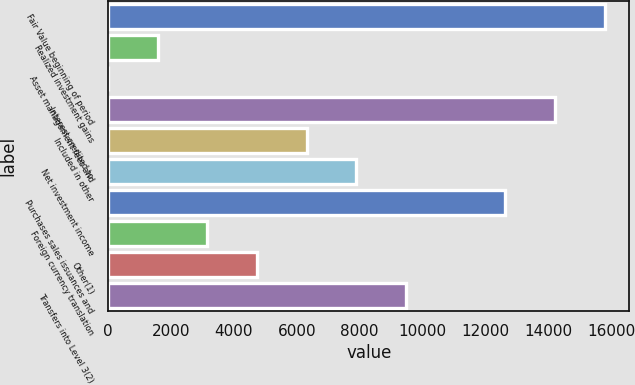<chart> <loc_0><loc_0><loc_500><loc_500><bar_chart><fcel>Fair Value beginning of period<fcel>Realized investment gains<fcel>Asset management fees and<fcel>Interest credited to<fcel>Included in other<fcel>Net investment income<fcel>Purchases sales issuances and<fcel>Foreign currency translation<fcel>Other(1)<fcel>Transfers into Level 3(2)<nl><fcel>15792<fcel>1579.45<fcel>0.28<fcel>14212.8<fcel>6316.96<fcel>7896.13<fcel>12633.6<fcel>3158.62<fcel>4737.79<fcel>9475.3<nl></chart> 